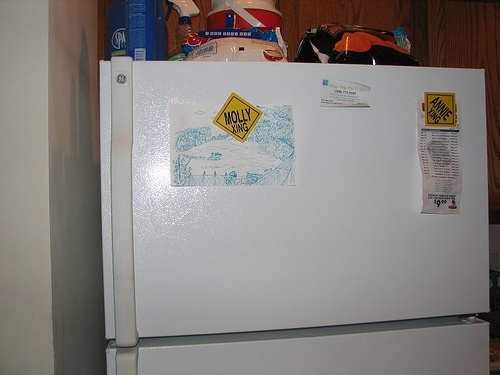Describe the objects in this image and their specific colors. I can see a refrigerator in gray, darkgray, and lightgray tones in this image. 